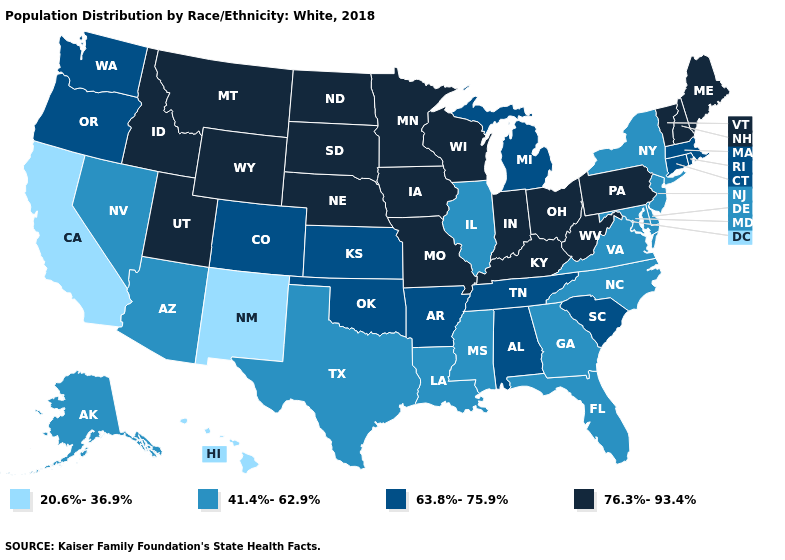Name the states that have a value in the range 41.4%-62.9%?
Write a very short answer. Alaska, Arizona, Delaware, Florida, Georgia, Illinois, Louisiana, Maryland, Mississippi, Nevada, New Jersey, New York, North Carolina, Texas, Virginia. What is the highest value in the USA?
Be succinct. 76.3%-93.4%. Does the first symbol in the legend represent the smallest category?
Write a very short answer. Yes. What is the value of Kentucky?
Keep it brief. 76.3%-93.4%. Does Georgia have the highest value in the USA?
Quick response, please. No. Does North Dakota have the highest value in the USA?
Short answer required. Yes. Which states have the lowest value in the USA?
Give a very brief answer. California, Hawaii, New Mexico. Name the states that have a value in the range 41.4%-62.9%?
Quick response, please. Alaska, Arizona, Delaware, Florida, Georgia, Illinois, Louisiana, Maryland, Mississippi, Nevada, New Jersey, New York, North Carolina, Texas, Virginia. What is the value of Illinois?
Answer briefly. 41.4%-62.9%. Does Maryland have a higher value than Rhode Island?
Write a very short answer. No. Among the states that border Nebraska , does Missouri have the lowest value?
Be succinct. No. Among the states that border Kentucky , does Tennessee have the lowest value?
Concise answer only. No. What is the value of Iowa?
Quick response, please. 76.3%-93.4%. Name the states that have a value in the range 41.4%-62.9%?
Give a very brief answer. Alaska, Arizona, Delaware, Florida, Georgia, Illinois, Louisiana, Maryland, Mississippi, Nevada, New Jersey, New York, North Carolina, Texas, Virginia. Name the states that have a value in the range 76.3%-93.4%?
Give a very brief answer. Idaho, Indiana, Iowa, Kentucky, Maine, Minnesota, Missouri, Montana, Nebraska, New Hampshire, North Dakota, Ohio, Pennsylvania, South Dakota, Utah, Vermont, West Virginia, Wisconsin, Wyoming. 